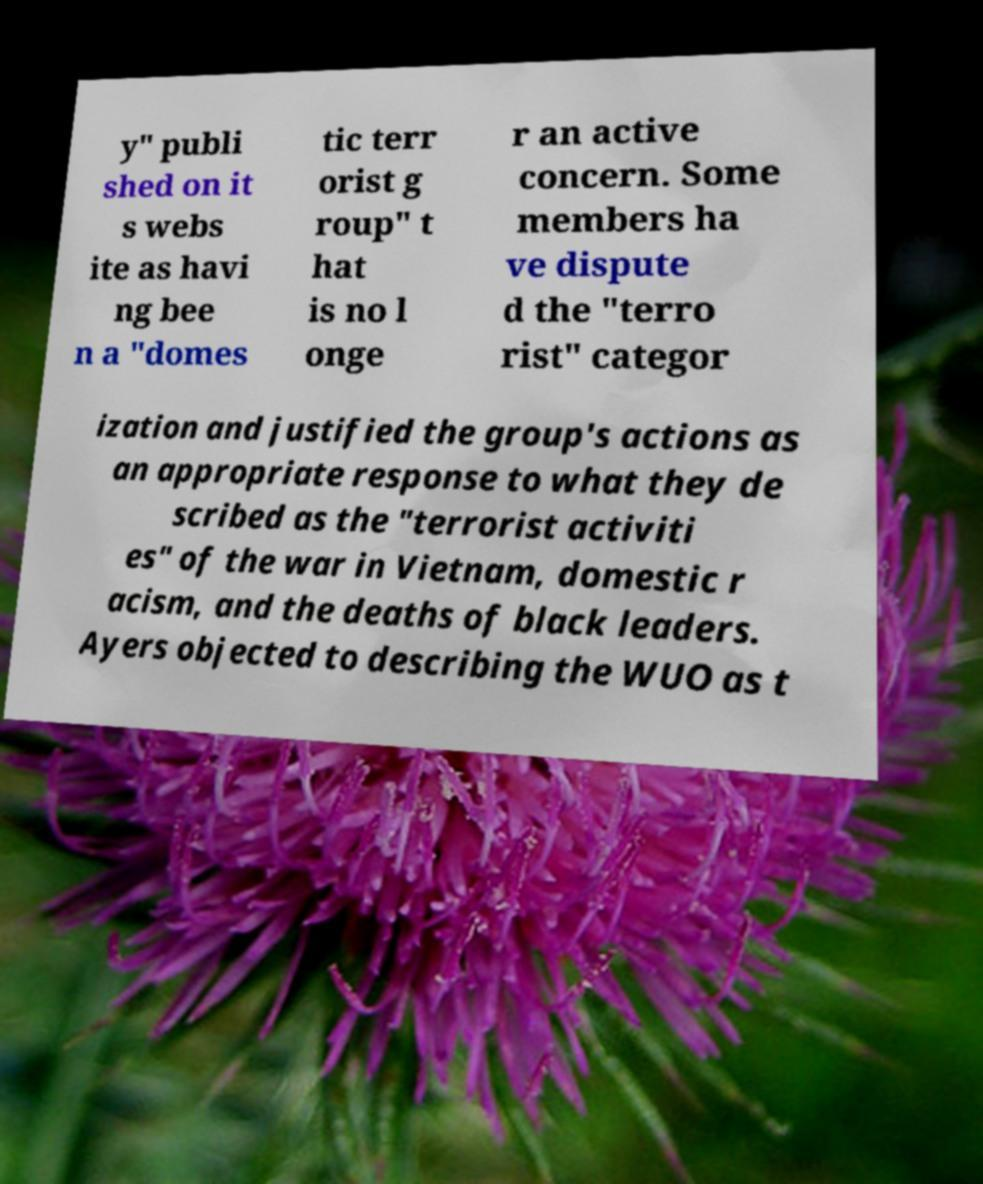Please read and relay the text visible in this image. What does it say? y" publi shed on it s webs ite as havi ng bee n a "domes tic terr orist g roup" t hat is no l onge r an active concern. Some members ha ve dispute d the "terro rist" categor ization and justified the group's actions as an appropriate response to what they de scribed as the "terrorist activiti es" of the war in Vietnam, domestic r acism, and the deaths of black leaders. Ayers objected to describing the WUO as t 